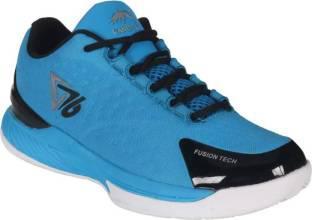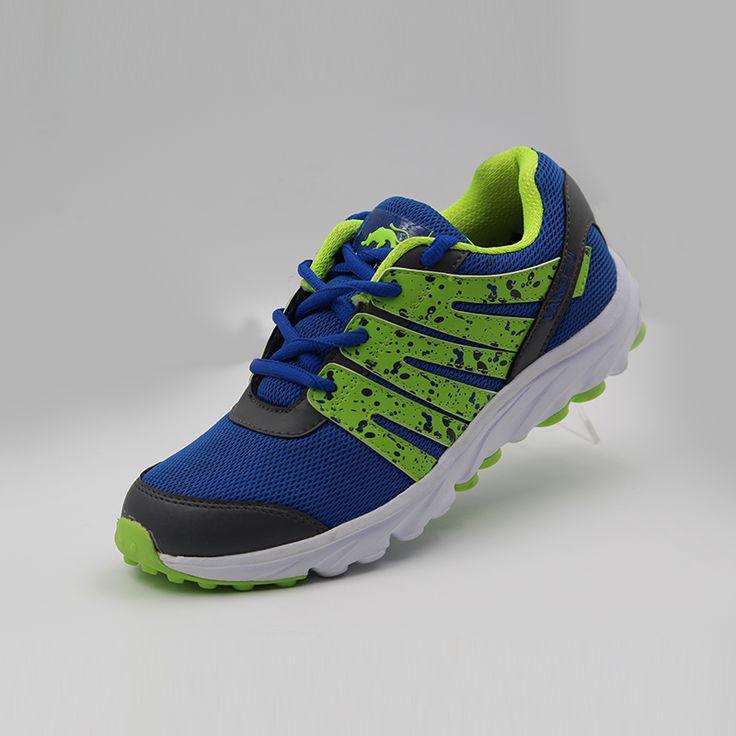The first image is the image on the left, the second image is the image on the right. Examine the images to the left and right. Is the description "The toe of the shoe in the image on the right is pointed to the left." accurate? Answer yes or no. Yes. The first image is the image on the left, the second image is the image on the right. Assess this claim about the two images: "Right image contains one shoe tilted and facing rightward, with a cat silhouette somewhere on it.". Correct or not? Answer yes or no. No. 